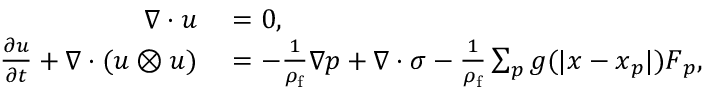Convert formula to latex. <formula><loc_0><loc_0><loc_500><loc_500>\begin{array} { r l } { \nabla \cdot u } & = 0 , } \\ { \frac { \partial u } { \partial t } + \nabla \cdot ( u \otimes u ) } & = - \frac { 1 } { \rho _ { f } } \nabla p + \nabla \cdot \sigma - \frac { 1 } { \rho _ { f } } \sum _ { p } g ( | x - x _ { p } | ) F _ { p } , } \end{array}</formula> 